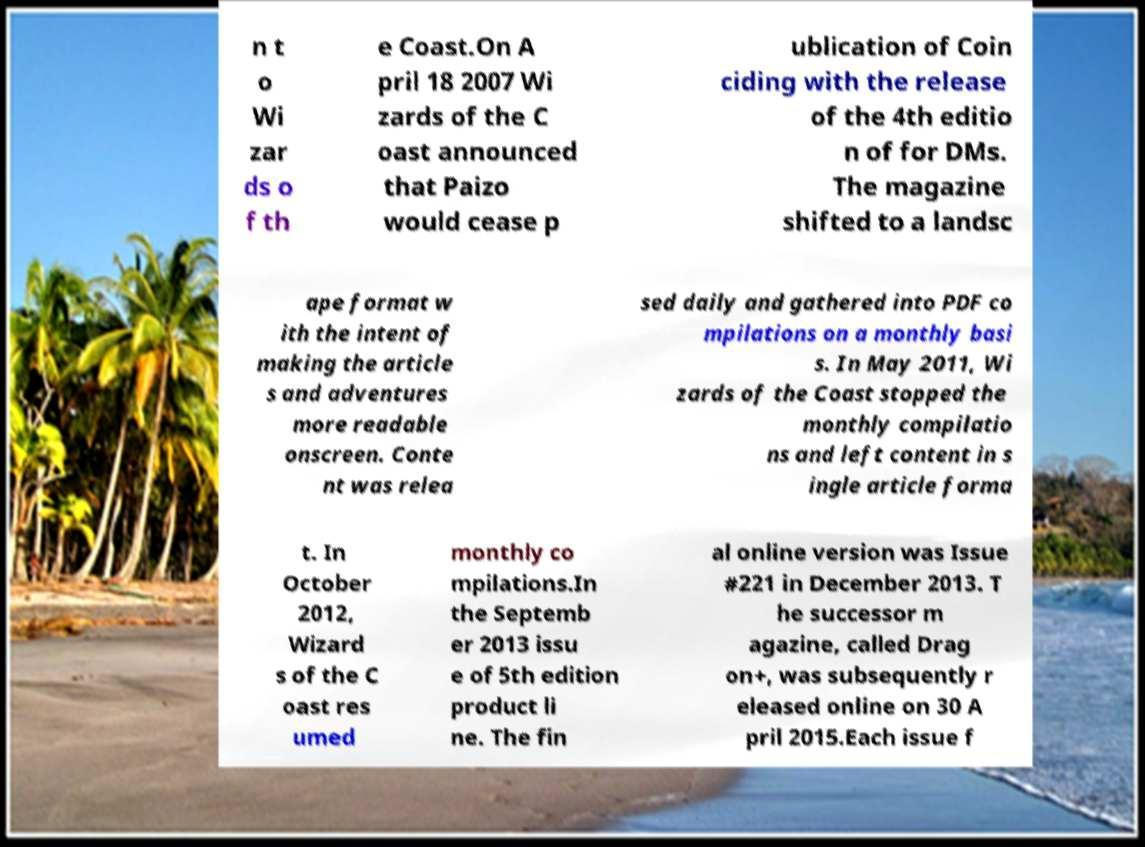I need the written content from this picture converted into text. Can you do that? n t o Wi zar ds o f th e Coast.On A pril 18 2007 Wi zards of the C oast announced that Paizo would cease p ublication of Coin ciding with the release of the 4th editio n of for DMs. The magazine shifted to a landsc ape format w ith the intent of making the article s and adventures more readable onscreen. Conte nt was relea sed daily and gathered into PDF co mpilations on a monthly basi s. In May 2011, Wi zards of the Coast stopped the monthly compilatio ns and left content in s ingle article forma t. In October 2012, Wizard s of the C oast res umed monthly co mpilations.In the Septemb er 2013 issu e of 5th edition product li ne. The fin al online version was Issue #221 in December 2013. T he successor m agazine, called Drag on+, was subsequently r eleased online on 30 A pril 2015.Each issue f 